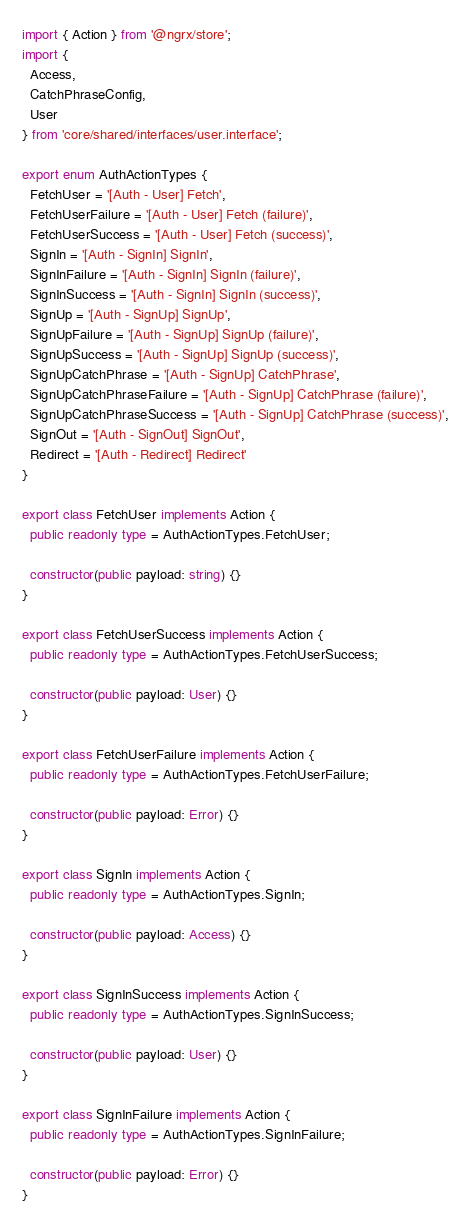Convert code to text. <code><loc_0><loc_0><loc_500><loc_500><_TypeScript_>import { Action } from '@ngrx/store';
import {
  Access,
  CatchPhraseConfig,
  User
} from 'core/shared/interfaces/user.interface';

export enum AuthActionTypes {
  FetchUser = '[Auth - User] Fetch',
  FetchUserFailure = '[Auth - User] Fetch (failure)',
  FetchUserSuccess = '[Auth - User] Fetch (success)',
  SignIn = '[Auth - SignIn] SignIn',
  SignInFailure = '[Auth - SignIn] SignIn (failure)',
  SignInSuccess = '[Auth - SignIn] SignIn (success)',
  SignUp = '[Auth - SignUp] SignUp',
  SignUpFailure = '[Auth - SignUp] SignUp (failure)',
  SignUpSuccess = '[Auth - SignUp] SignUp (success)',
  SignUpCatchPhrase = '[Auth - SignUp] CatchPhrase',
  SignUpCatchPhraseFailure = '[Auth - SignUp] CatchPhrase (failure)',
  SignUpCatchPhraseSuccess = '[Auth - SignUp] CatchPhrase (success)',
  SignOut = '[Auth - SignOut] SignOut',
  Redirect = '[Auth - Redirect] Redirect'
}

export class FetchUser implements Action {
  public readonly type = AuthActionTypes.FetchUser;

  constructor(public payload: string) {}
}

export class FetchUserSuccess implements Action {
  public readonly type = AuthActionTypes.FetchUserSuccess;

  constructor(public payload: User) {}
}

export class FetchUserFailure implements Action {
  public readonly type = AuthActionTypes.FetchUserFailure;

  constructor(public payload: Error) {}
}

export class SignIn implements Action {
  public readonly type = AuthActionTypes.SignIn;

  constructor(public payload: Access) {}
}

export class SignInSuccess implements Action {
  public readonly type = AuthActionTypes.SignInSuccess;

  constructor(public payload: User) {}
}

export class SignInFailure implements Action {
  public readonly type = AuthActionTypes.SignInFailure;

  constructor(public payload: Error) {}
}
</code> 